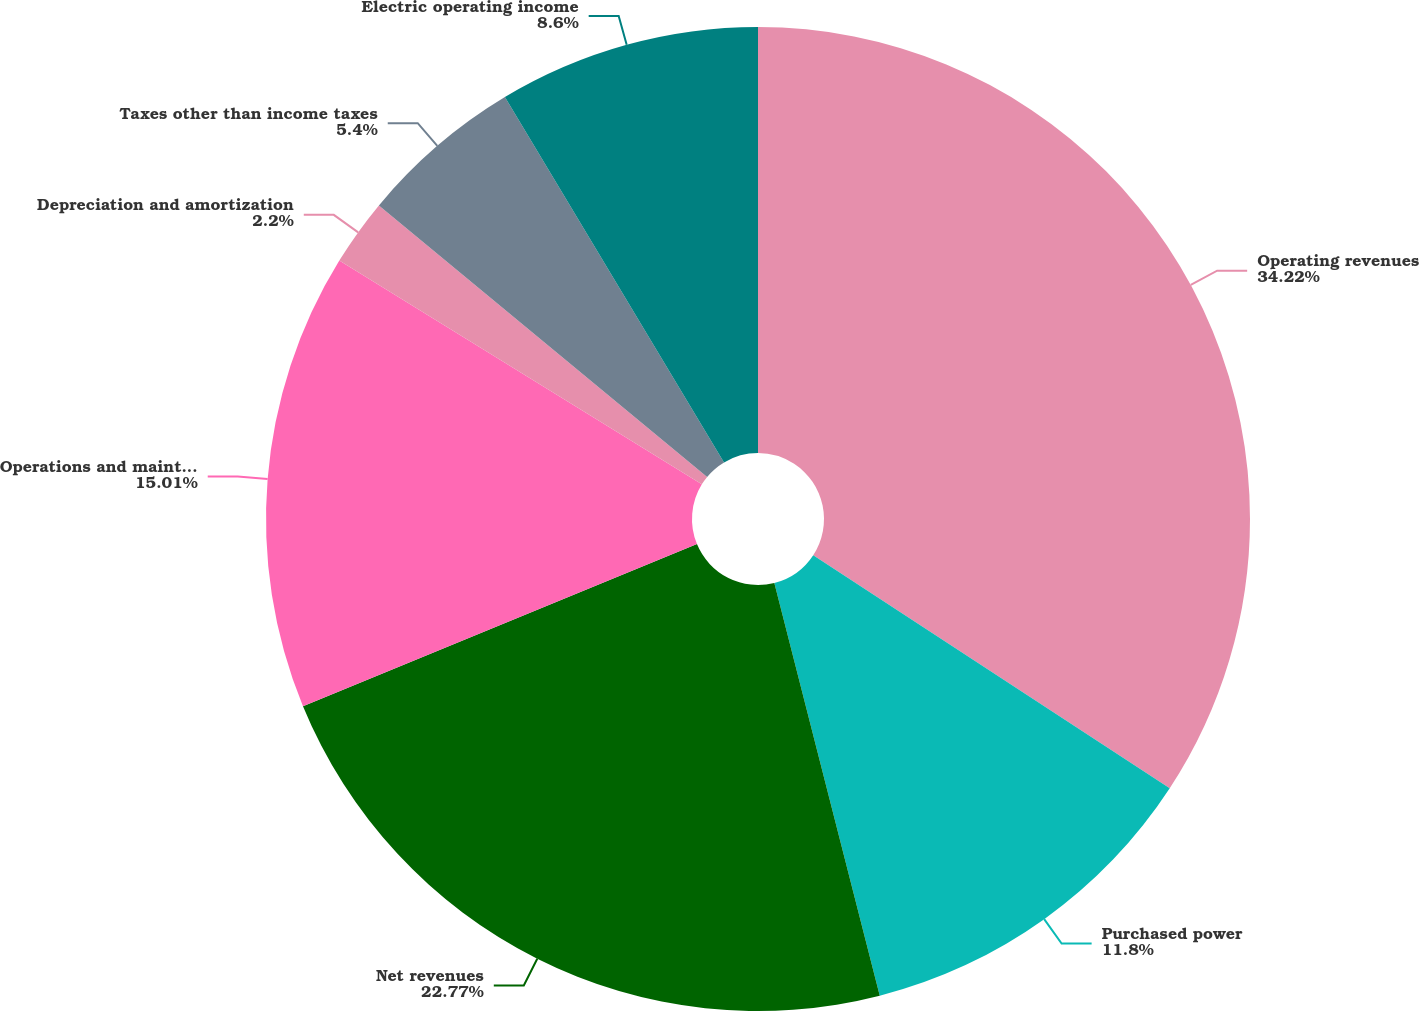Convert chart. <chart><loc_0><loc_0><loc_500><loc_500><pie_chart><fcel>Operating revenues<fcel>Purchased power<fcel>Net revenues<fcel>Operations and maintenance<fcel>Depreciation and amortization<fcel>Taxes other than income taxes<fcel>Electric operating income<nl><fcel>34.22%<fcel>11.8%<fcel>22.77%<fcel>15.01%<fcel>2.2%<fcel>5.4%<fcel>8.6%<nl></chart> 